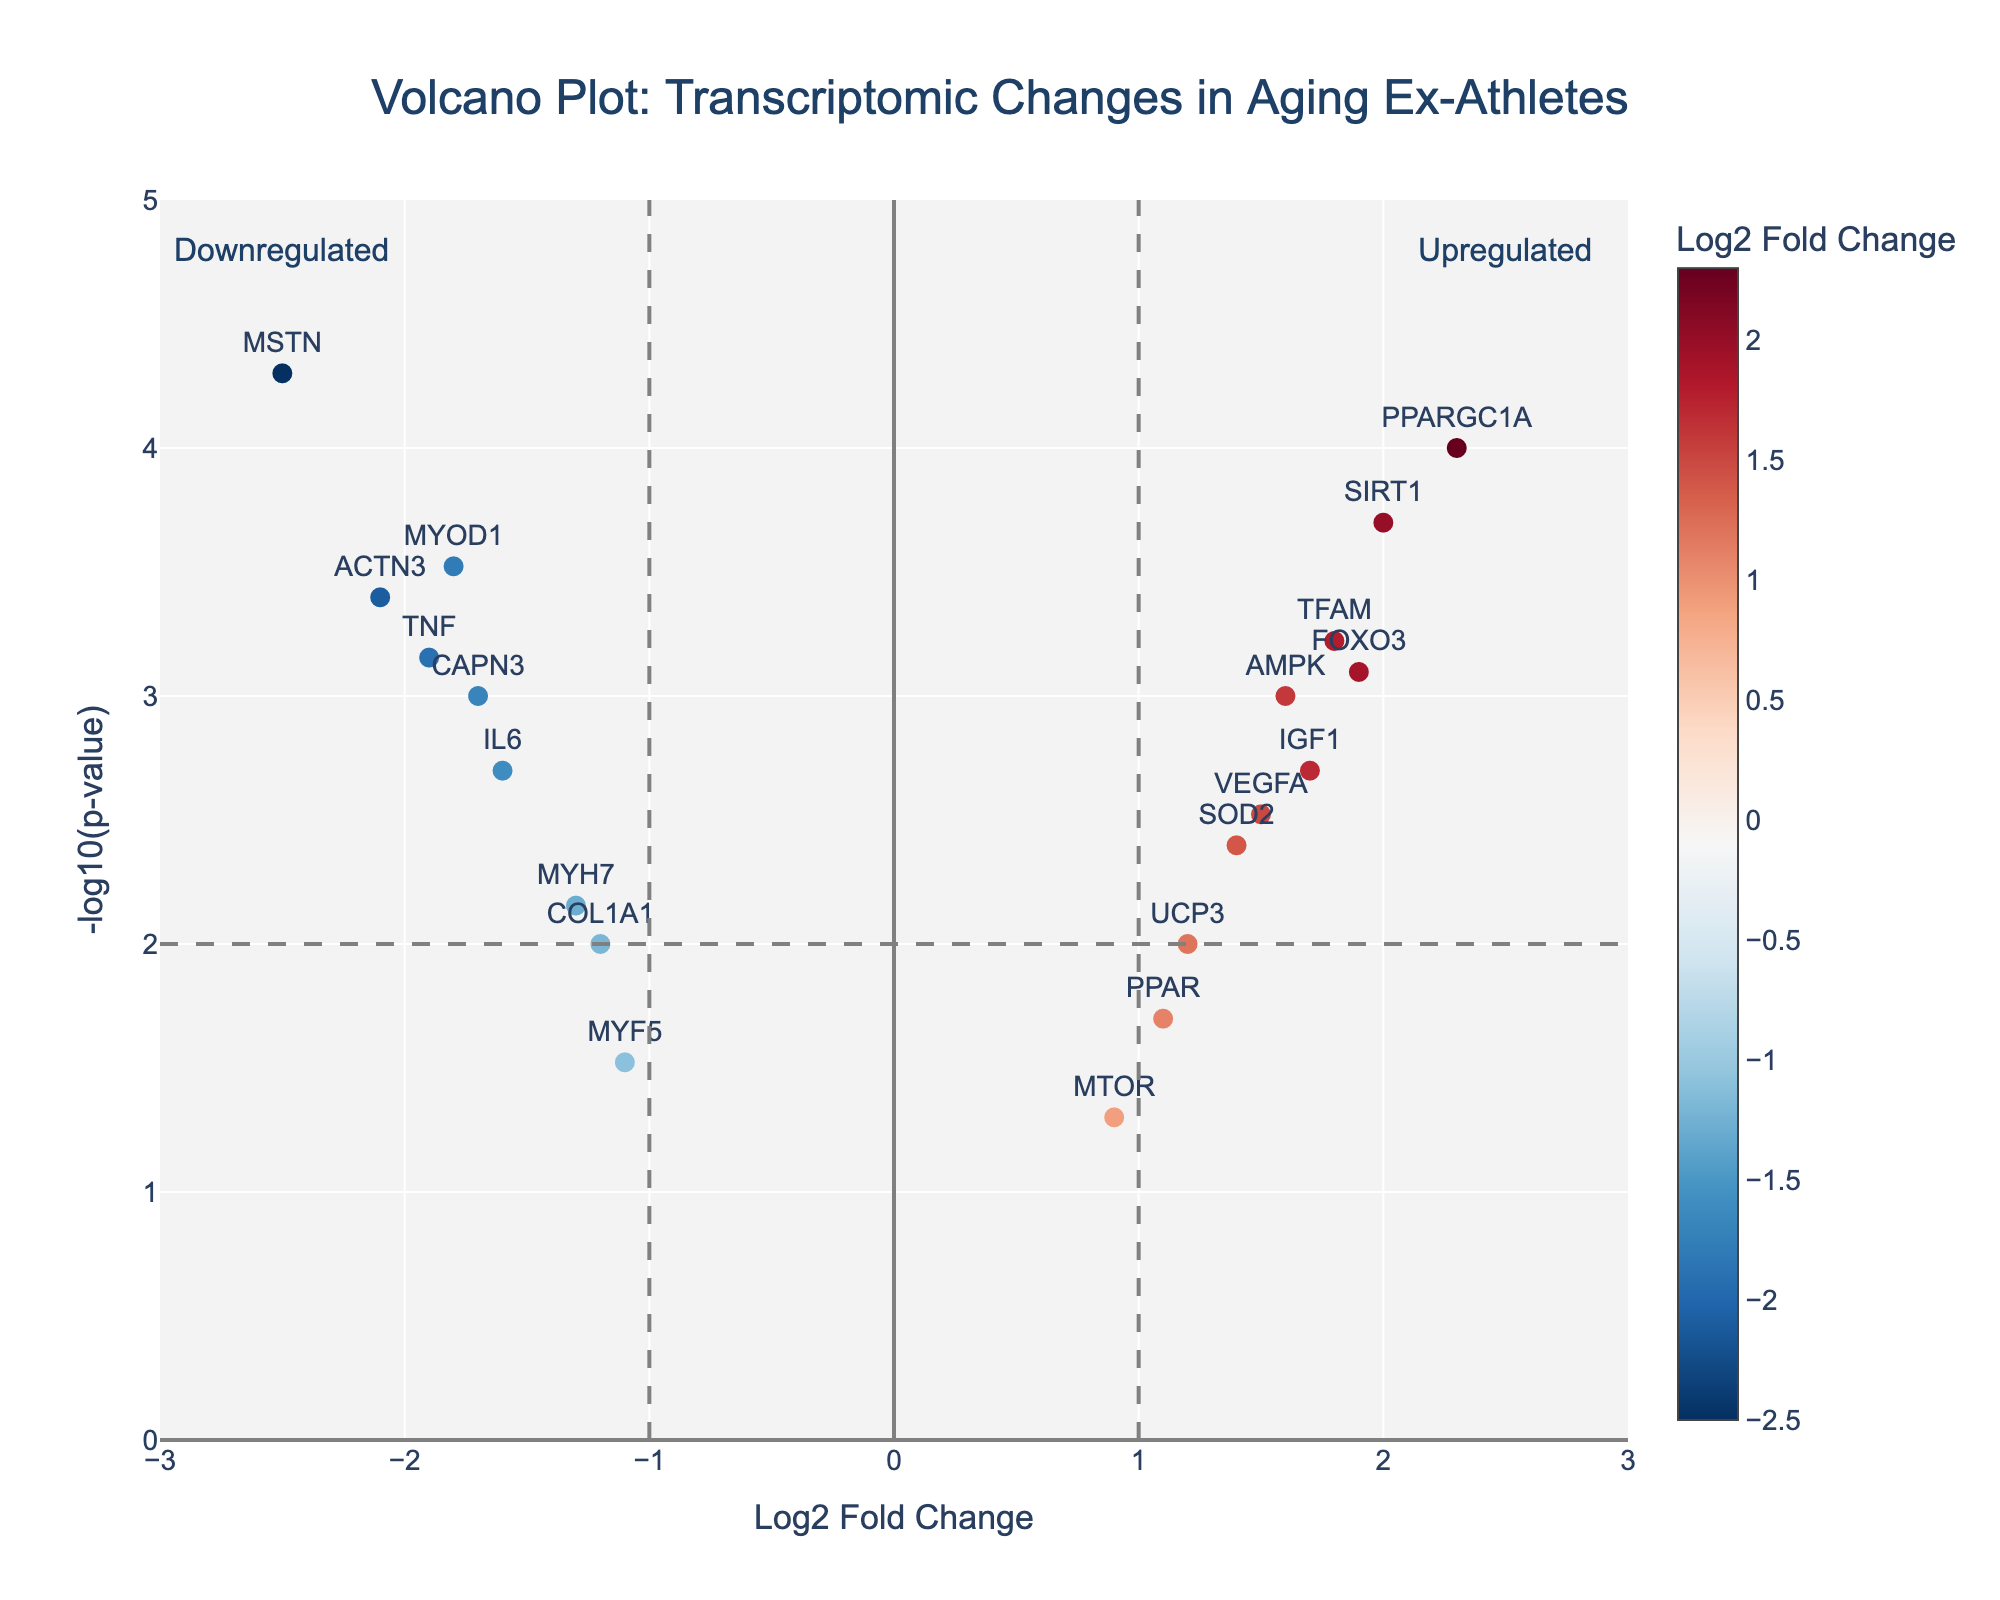what is the title of the plot? The title is displayed at the top-center of the plot, indicating the main subject of the plot.
Answer: Volcano Plot: Transcriptomic Changes in Aging Ex-Athletes Which gene has the highest -log10(p-value)? By looking at the y-axis, we find the point that is vertically highest. MSTN is significantly above other genes.
Answer: MSTN How many genes are upregulated and have a significant p-value (p < 0.05)? Upregulated genes are those with a positive Log2FoldChange. We filter the genes above the 2 on the y-axis (significant) and with x > 0.
Answer: 9 Which genes have a Log2FoldChange greater than 2? Find the gene labels in the plot with their position at x > 2. PPARGC1A & SIRT1 are greater than 2.
Answer: PPARGC1A, SIRT1 Which gene is the most downregulated, and what is its -log10(p-value)? The most downregulated gene has the lowest Log2FoldChange. Look at the leftmost point. Then find its y-axis value.
Answer: MSTN, 4.3 What is the Log2FoldChange and -log10(p-value) of IL6? Locate the IL6 data point. Observe its coordinates in the x and y axes.
Answer: -1.6, 2.7 Are there any genes that exhibit both a high Log2FoldChange and high -log10(p-value)? Name one. Look for genes in the upper right sector. Genes need both x > 2 and high y-axis value.
Answer: PPARGC1A Between ACTN3 and MYOD1, which gene is more downregulated and by how much? Determine Log2FoldChange for both. Subtract the values. Log2FoldChange(ACTN3) < Log2FoldChange(MYOD1)
Answer: ACTN3, 0.3 Which genes are within -1 < Log2FoldChange < 1 and have a significant p-value (p < 0.05)? Locate the genes in the central band (within -1 and 1 in x-axis) under 2 in y-axis, alongside significant p-value threshold.
Answer: MTOR, MYF5 Are there any genes with p-values above 0.05? These genes fall at or below the lower threshold line as p > 0.05. Their y-axis value is less than 1.3.
Answer: MTOR 